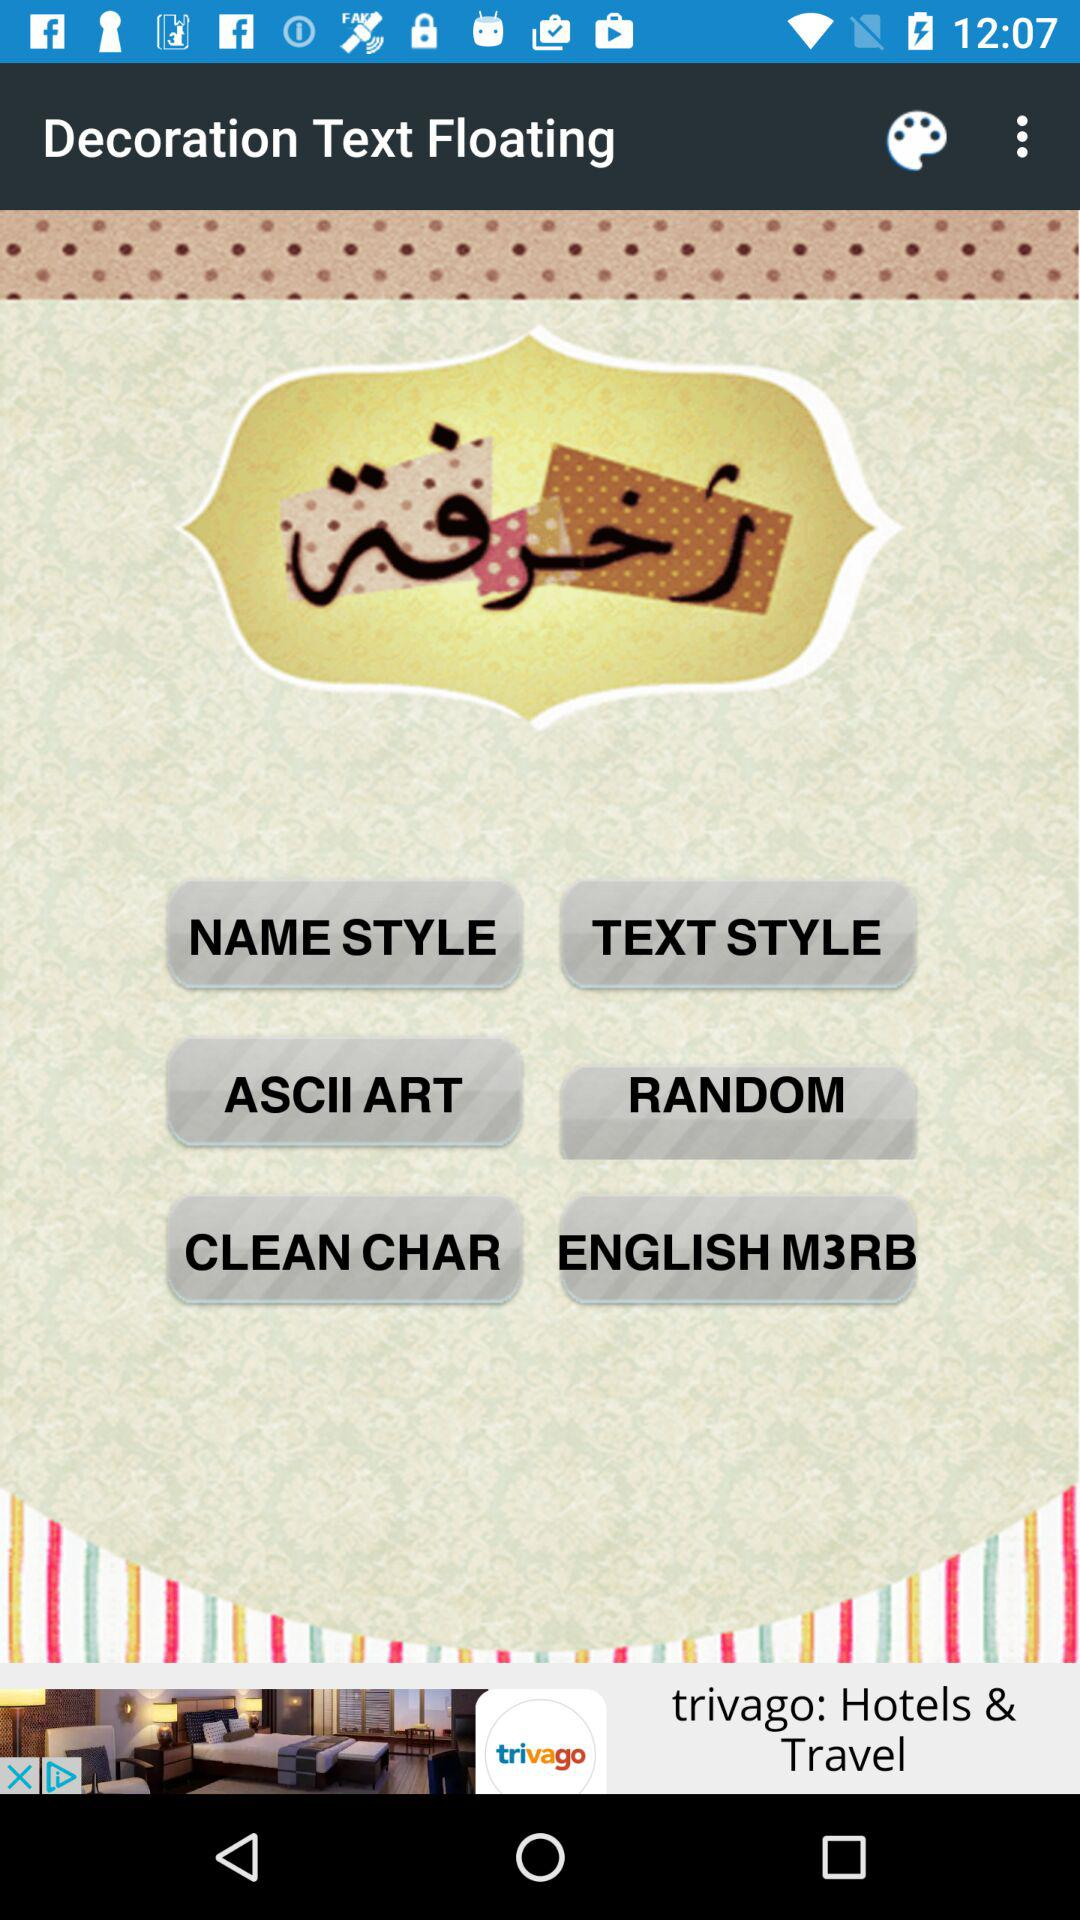What is the name of the application? The name of the application is "Decoration Text Floating". 